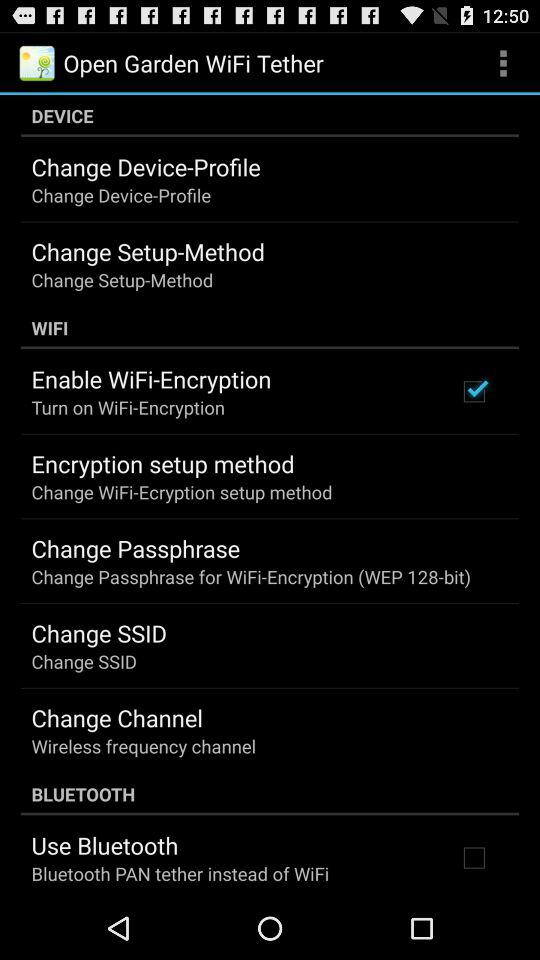Which setting is checked? The checked setting is "Enable WiFi-Encryption". 